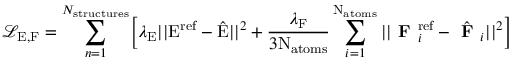Convert formula to latex. <formula><loc_0><loc_0><loc_500><loc_500>\mathcal { L } _ { E , F } = \sum _ { n = 1 } ^ { N _ { s t r u c t u r e s } } \left [ \lambda _ { E } | | E ^ { r e f } - \hat { E } | | ^ { 2 } + \frac { \lambda _ { F } } { 3 N _ { a t o m s } } \sum _ { i = 1 } ^ { N _ { a t o m s } } | | F _ { i } ^ { r e f } - \hat { F } _ { i } | | ^ { 2 } \right ]</formula> 